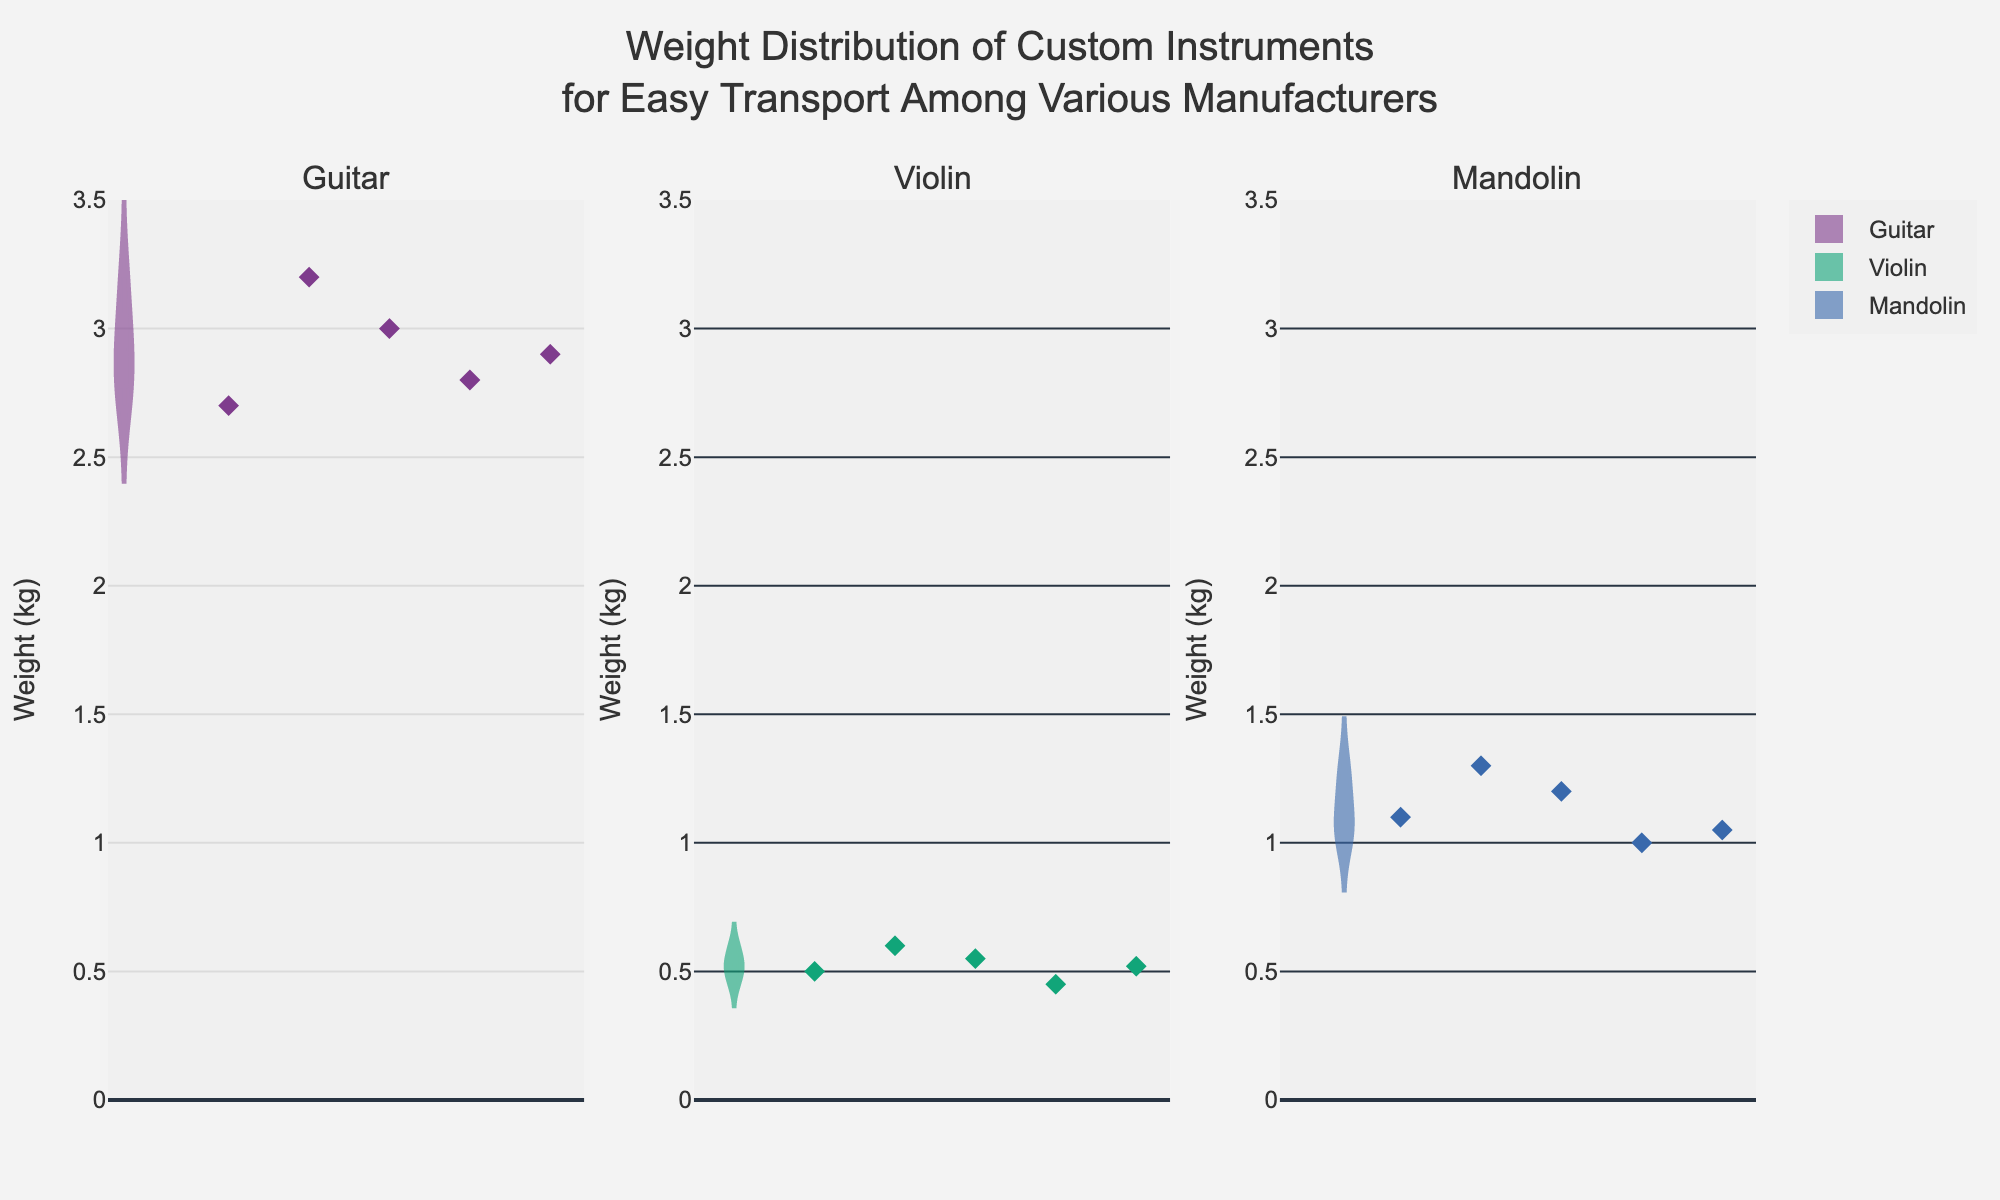What's the title of the plot? The title is placed at the top center of the plot, indicating the overall theme or data being visualized.
Answer: Weight Distribution of Custom Instruments for Easy Transport Among Various Manufacturers What is the weight range used in the y-axis for all subplots? The y-axis for all subplots shows a weight range, which is the same for ease of comparison. It runs from 0 to 3.5 kg as visible from the axis labeling.
Answer: 0 to 3.5 kg Which instrument type has the highest mean weight across manufacturers? The mean lines in the violin plots represent the average weights. The Guitar plot shows the mean line at a higher point than the Violin and Mandolin plots.
Answer: Guitar How do the weights of Yamaha Violins compare to other manufacturers? Jittered points for Yamaha Violins show a weight of 0.5 kg, aligning closely with other violin weights from other manufacturers, indicating little variation in violin weights.
Answer: Similar How many data points are there for each instrument type? Each instrument type section (Guitar, Violin, Mandolin) shows five data points, corresponding to five different manufacturers. Visually, this is evident from the number of jittered points for each type.
Answer: Five Which instrument type has the lowest minimum weight? The Violin chart shows the lowest minimum weight, evidenced by the lowest points and violin plot's lower bounds around 0.45 kg.
Answer: Violin What's the weight difference between the heaviest and lightest Guitar? The heaviest Guitar weighs about 3.2 kg (Fender), and the lightest weighs about 2.7 kg (Yamaha). The difference is calculated as 3.2 - 2.7.
Answer: 0.5 kg Who is the manufacturer of the heaviest Mandolin? By observing the jittered points in the Mandolin subplot, the heaviest point aligns with the 1.3 kg weight, which belongs to Fender.
Answer: Fender What's the median weight for Violins? The median is often visible as the middle line in the box of a violin plot. The median line for Violins falls around 0.52 kg.
Answer: 0.52 kg 